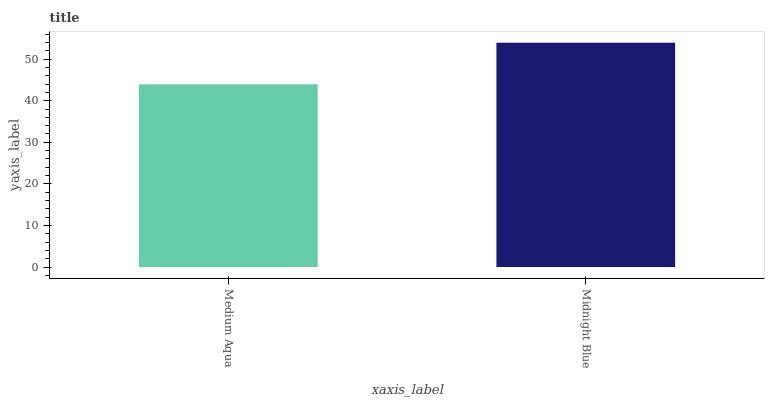Is Medium Aqua the minimum?
Answer yes or no. Yes. Is Midnight Blue the maximum?
Answer yes or no. Yes. Is Midnight Blue the minimum?
Answer yes or no. No. Is Midnight Blue greater than Medium Aqua?
Answer yes or no. Yes. Is Medium Aqua less than Midnight Blue?
Answer yes or no. Yes. Is Medium Aqua greater than Midnight Blue?
Answer yes or no. No. Is Midnight Blue less than Medium Aqua?
Answer yes or no. No. Is Midnight Blue the high median?
Answer yes or no. Yes. Is Medium Aqua the low median?
Answer yes or no. Yes. Is Medium Aqua the high median?
Answer yes or no. No. Is Midnight Blue the low median?
Answer yes or no. No. 